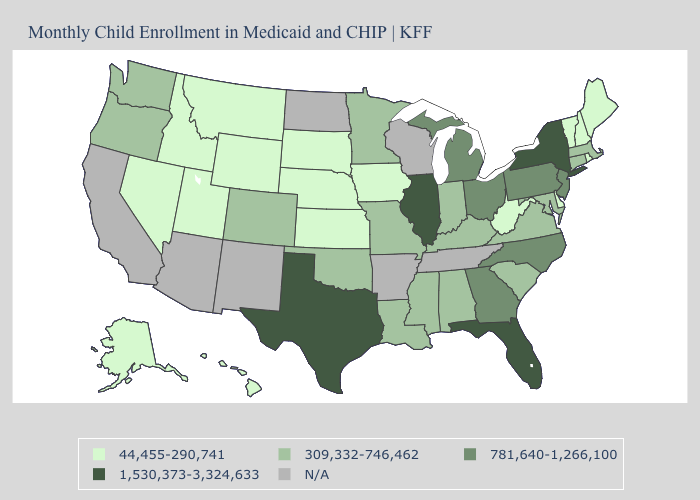Does Florida have the lowest value in the South?
Short answer required. No. Name the states that have a value in the range 309,332-746,462?
Quick response, please. Alabama, Colorado, Connecticut, Indiana, Kentucky, Louisiana, Maryland, Massachusetts, Minnesota, Mississippi, Missouri, Oklahoma, Oregon, South Carolina, Virginia, Washington. What is the value of Wisconsin?
Give a very brief answer. N/A. What is the lowest value in the Northeast?
Concise answer only. 44,455-290,741. Name the states that have a value in the range 1,530,373-3,324,633?
Write a very short answer. Florida, Illinois, New York, Texas. Which states have the highest value in the USA?
Short answer required. Florida, Illinois, New York, Texas. What is the value of Kansas?
Keep it brief. 44,455-290,741. Which states have the lowest value in the USA?
Concise answer only. Alaska, Delaware, Hawaii, Idaho, Iowa, Kansas, Maine, Montana, Nebraska, Nevada, New Hampshire, Rhode Island, South Dakota, Utah, Vermont, West Virginia, Wyoming. Among the states that border Tennessee , which have the highest value?
Be succinct. Georgia, North Carolina. Name the states that have a value in the range 44,455-290,741?
Give a very brief answer. Alaska, Delaware, Hawaii, Idaho, Iowa, Kansas, Maine, Montana, Nebraska, Nevada, New Hampshire, Rhode Island, South Dakota, Utah, Vermont, West Virginia, Wyoming. Does Hawaii have the highest value in the USA?
Quick response, please. No. What is the value of Kentucky?
Give a very brief answer. 309,332-746,462. Among the states that border South Dakota , does Wyoming have the highest value?
Write a very short answer. No. 